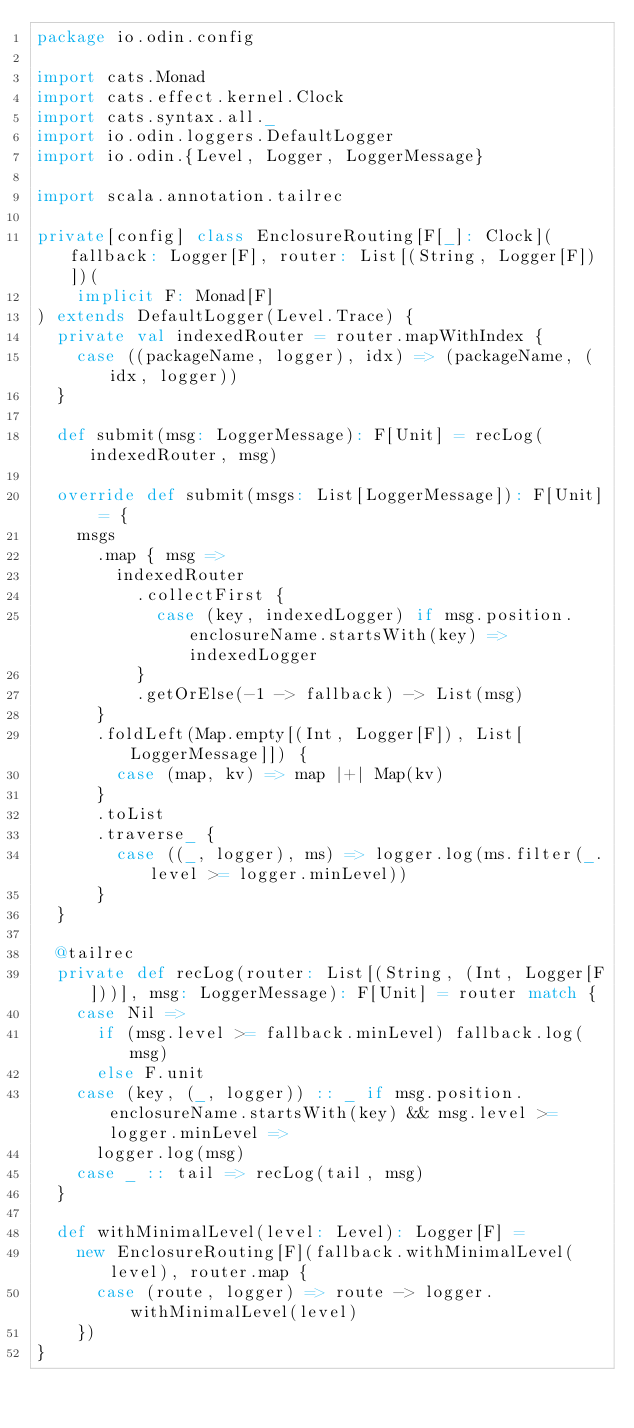<code> <loc_0><loc_0><loc_500><loc_500><_Scala_>package io.odin.config

import cats.Monad
import cats.effect.kernel.Clock
import cats.syntax.all._
import io.odin.loggers.DefaultLogger
import io.odin.{Level, Logger, LoggerMessage}

import scala.annotation.tailrec

private[config] class EnclosureRouting[F[_]: Clock](fallback: Logger[F], router: List[(String, Logger[F])])(
    implicit F: Monad[F]
) extends DefaultLogger(Level.Trace) {
  private val indexedRouter = router.mapWithIndex {
    case ((packageName, logger), idx) => (packageName, (idx, logger))
  }

  def submit(msg: LoggerMessage): F[Unit] = recLog(indexedRouter, msg)

  override def submit(msgs: List[LoggerMessage]): F[Unit] = {
    msgs
      .map { msg =>
        indexedRouter
          .collectFirst {
            case (key, indexedLogger) if msg.position.enclosureName.startsWith(key) => indexedLogger
          }
          .getOrElse(-1 -> fallback) -> List(msg)
      }
      .foldLeft(Map.empty[(Int, Logger[F]), List[LoggerMessage]]) {
        case (map, kv) => map |+| Map(kv)
      }
      .toList
      .traverse_ {
        case ((_, logger), ms) => logger.log(ms.filter(_.level >= logger.minLevel))
      }
  }

  @tailrec
  private def recLog(router: List[(String, (Int, Logger[F]))], msg: LoggerMessage): F[Unit] = router match {
    case Nil =>
      if (msg.level >= fallback.minLevel) fallback.log(msg)
      else F.unit
    case (key, (_, logger)) :: _ if msg.position.enclosureName.startsWith(key) && msg.level >= logger.minLevel =>
      logger.log(msg)
    case _ :: tail => recLog(tail, msg)
  }

  def withMinimalLevel(level: Level): Logger[F] =
    new EnclosureRouting[F](fallback.withMinimalLevel(level), router.map {
      case (route, logger) => route -> logger.withMinimalLevel(level)
    })
}
</code> 